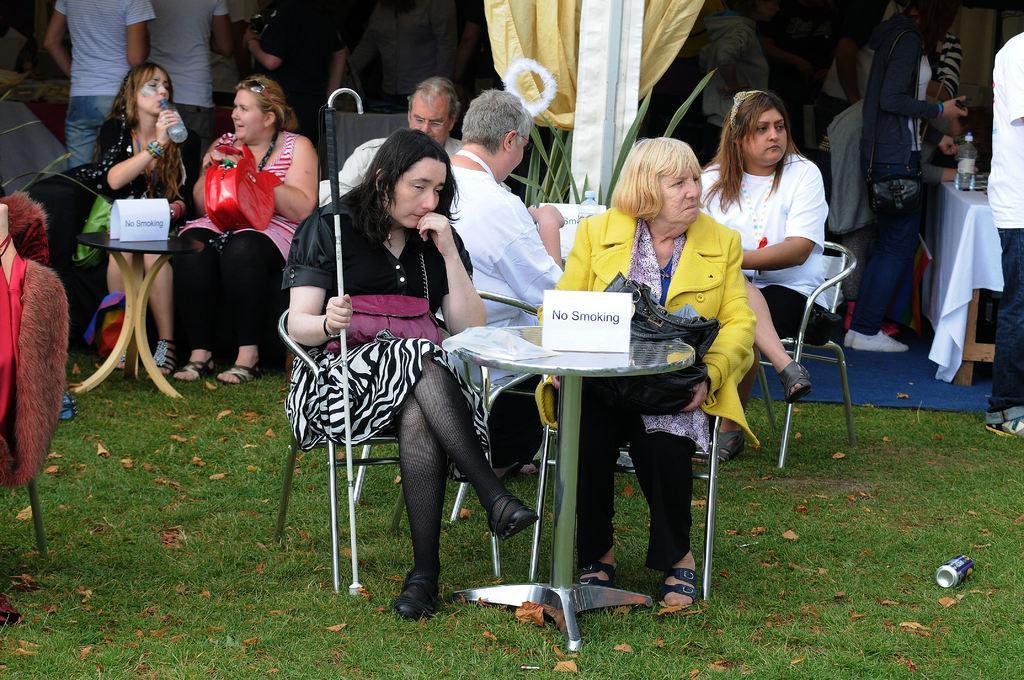In one or two sentences, can you explain what this image depicts? In this picture we can see many people sitting on the chairs near their tables on the grass ground. 